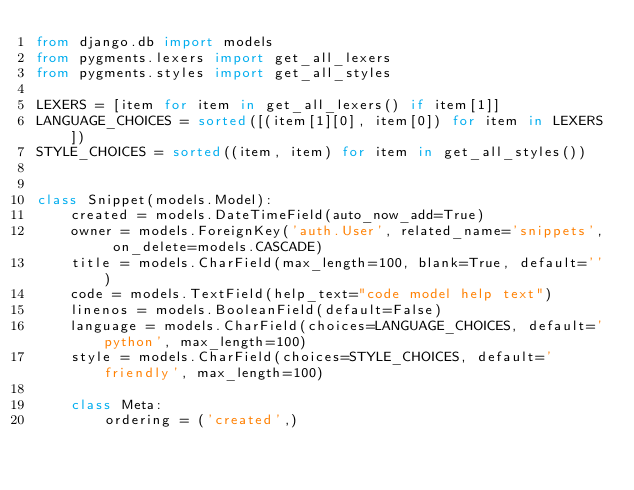<code> <loc_0><loc_0><loc_500><loc_500><_Python_>from django.db import models
from pygments.lexers import get_all_lexers
from pygments.styles import get_all_styles

LEXERS = [item for item in get_all_lexers() if item[1]]
LANGUAGE_CHOICES = sorted([(item[1][0], item[0]) for item in LEXERS])
STYLE_CHOICES = sorted((item, item) for item in get_all_styles())


class Snippet(models.Model):
    created = models.DateTimeField(auto_now_add=True)
    owner = models.ForeignKey('auth.User', related_name='snippets', on_delete=models.CASCADE)
    title = models.CharField(max_length=100, blank=True, default='')
    code = models.TextField(help_text="code model help text")
    linenos = models.BooleanField(default=False)
    language = models.CharField(choices=LANGUAGE_CHOICES, default='python', max_length=100)
    style = models.CharField(choices=STYLE_CHOICES, default='friendly', max_length=100)

    class Meta:
        ordering = ('created',)
</code> 